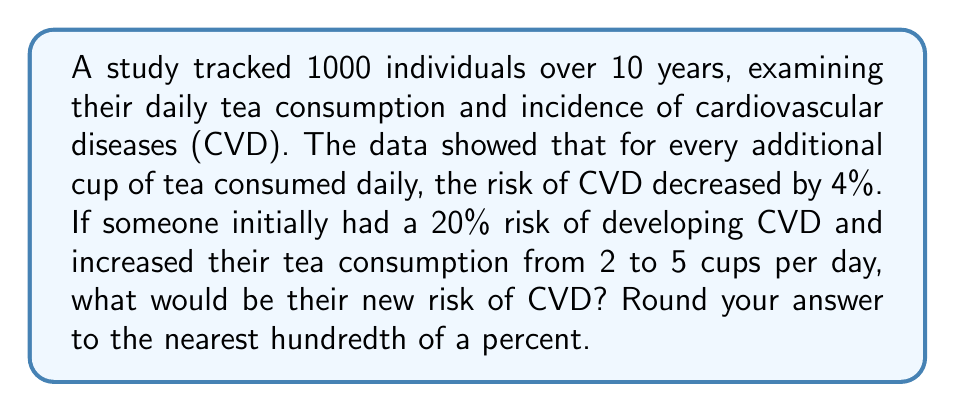Can you solve this math problem? Let's approach this step-by-step:

1) First, we need to calculate how many additional cups of tea are being consumed:
   $5 - 2 = 3$ additional cups

2) Each cup reduces the risk by 4%. For 3 cups, the total reduction is:
   $3 \times 4\% = 12\%$

3) We need to calculate 12% of the initial 20% risk:
   $12\% \text{ of } 20\% = 0.12 \times 20\% = 2.4\%$

4) This 2.4% is the amount by which the risk will be reduced. So we subtract it from the initial risk:
   $20\% - 2.4\% = 17.6\%$

5) To verify, we can use the compound reduction formula:
   $$\text{New Risk} = \text{Initial Risk} \times (1 - \text{Reduction per cup})^{\text{Number of additional cups}}$$
   $$= 20\% \times (1 - 0.04)^3$$
   $$= 20\% \times 0.884736$$
   $$= 17.69472\%$$

6) Rounding to the nearest hundredth of a percent:
   $17.69472\% \approx 17.69\%$

This confirms our earlier calculation (with a small difference due to rounding).
Answer: 17.69% 